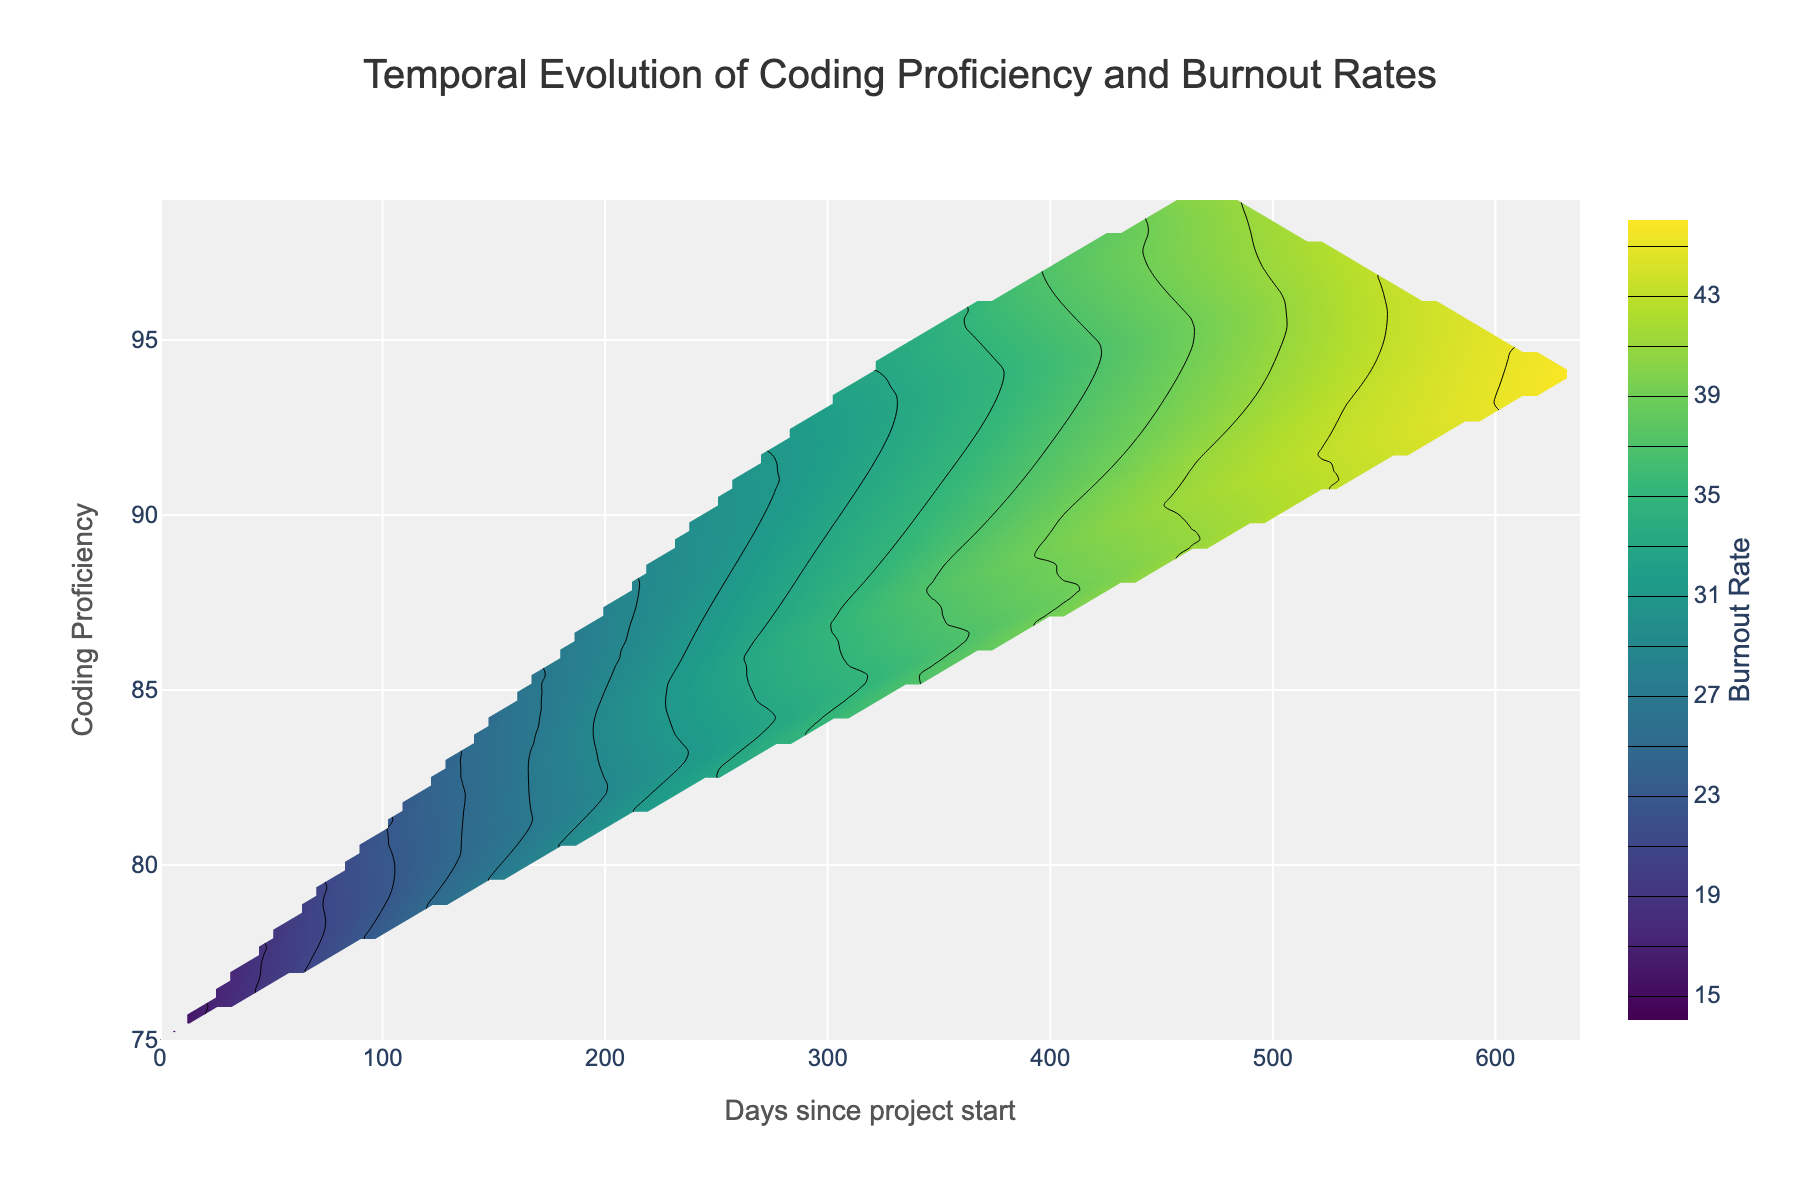What is the title of the plot? The title is usually found at the top of the plot and provides a brief description of what the plot is about. The title here is "Temporal Evolution of Coding Proficiency and Burnout Rates".
Answer: Temporal Evolution of Coding Proficiency and Burnout Rates What does the x-axis represent? The x-axis title is labeled and it indicates the horizontal dimension of the plot. The x-axis represents "Days since project start".
Answer: Days since project start What color gradient is used in the contour plot? The color gradient can be identified by examining the colors presented in the plot and the color scale provided. This contour plot uses the "Viridis" color scale that transitions from dark purple to yellow.
Answer: Viridis Between which dates did the coding proficiency reach its highest value? First, identify the highest coding proficiency on the y-axis, which is 99. Then, check the relevant timestamp range on the x-axis which indicates days since the project start. We see 99 proficiency occurs from around 360 to 485 days (Mar 2023 to May 2023).
Answer: Mar 2023 to May 2023 At what coding proficiency level does the burnout rate reach 46? Find the contour level marked 46 on the color scale, see where this level intersects with the coding proficiency values on the plot, which corresponds to a proficiency of about 94.
Answer: 94 How has the burnout rate evolved as coding proficiency increased from 75 to 99? Follow the contour lines starting from a coding proficiency of 75 up to 99. The burnout rate increases from 15 to 46 along this path.
Answer: Increased from 15 to 46 What is the range of coding proficiency where the burnout rate is between 30 and 40? Locate the contour lines for burnout rates of 30 and 40. The coding proficiency ranges from 90 to 99 within these burnout values.
Answer: 90 to 99 How many days into the project was the burnout rate 35? Find the contour labeled 35 and see where this intersects the x-axis, which represents days since the project start. This level intersects around 365 days.
Answer: 365 days During which months did the burnout rate fall between 34 and 38? Identify when the burnout contour levels of 34 to 38 occur. The corresponding months are from Dec 2022 (34) to Mar 2023 (38).
Answer: Dec 2022 to Mar 2023 